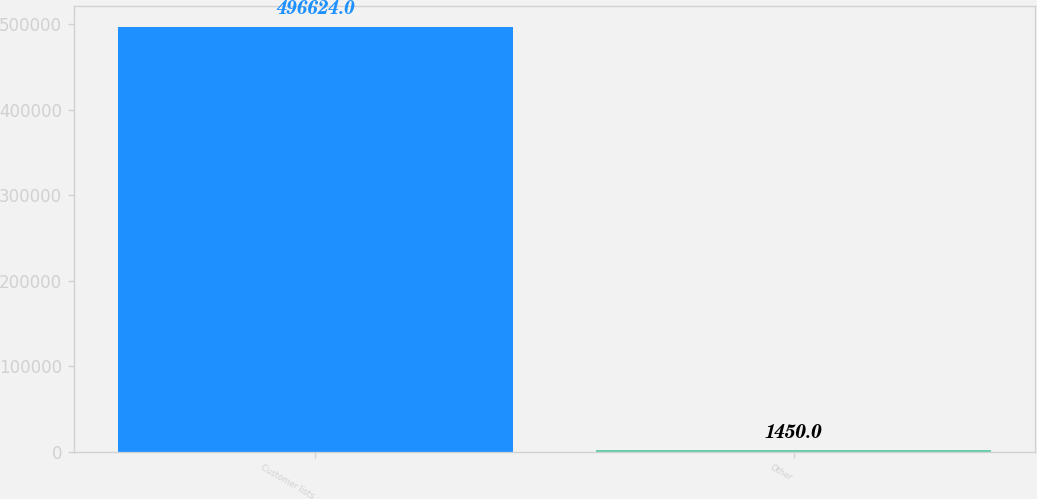Convert chart. <chart><loc_0><loc_0><loc_500><loc_500><bar_chart><fcel>Customer lists<fcel>Other<nl><fcel>496624<fcel>1450<nl></chart> 